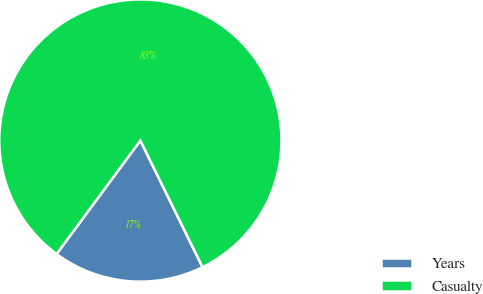<chart> <loc_0><loc_0><loc_500><loc_500><pie_chart><fcel>Years<fcel>Casualty<nl><fcel>17.39%<fcel>82.61%<nl></chart> 